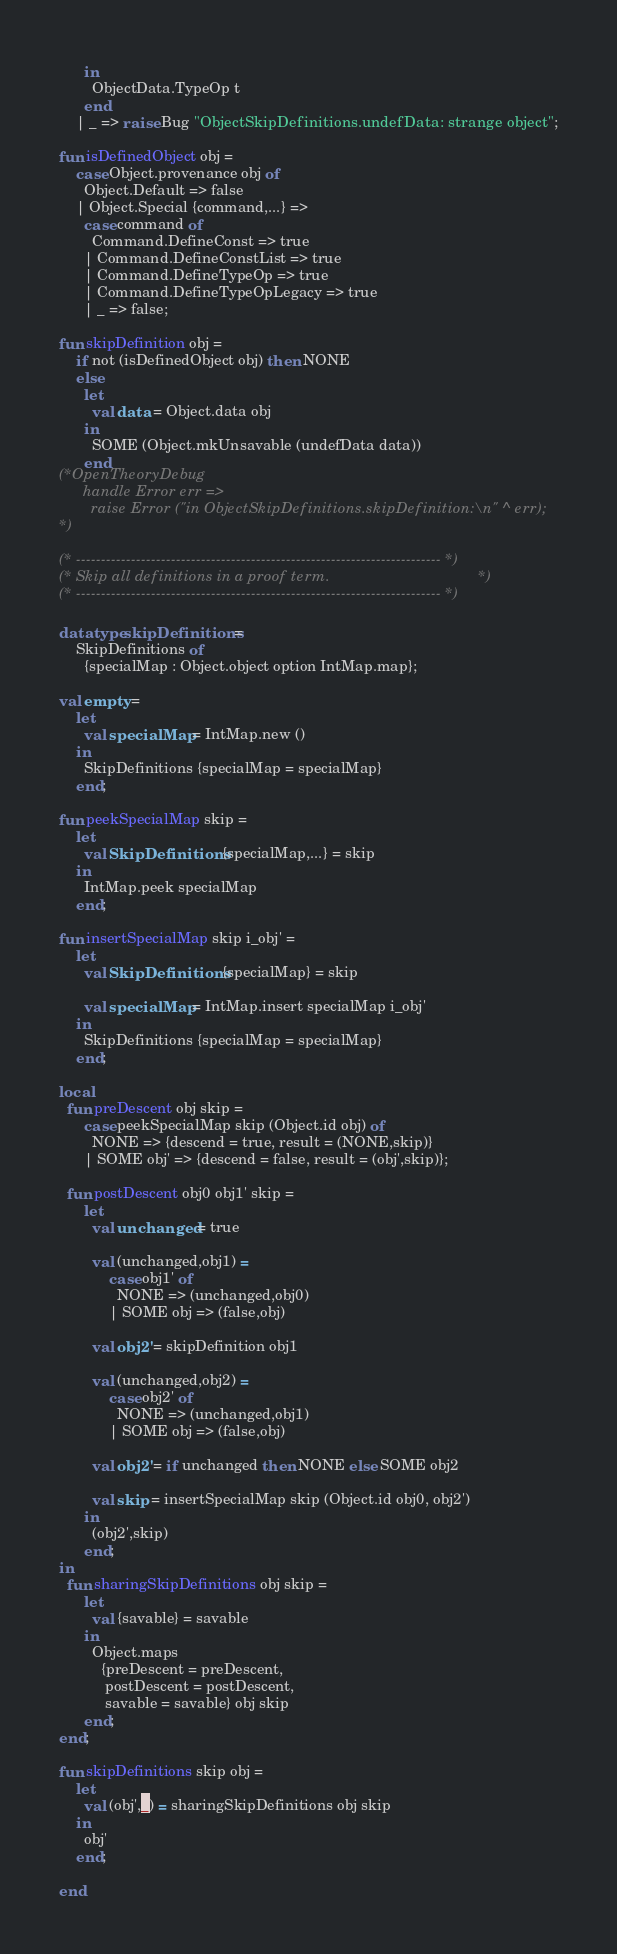<code> <loc_0><loc_0><loc_500><loc_500><_SML_>      in
        ObjectData.TypeOp t
      end
    | _ => raise Bug "ObjectSkipDefinitions.undefData: strange object";

fun isDefinedObject obj =
    case Object.provenance obj of
      Object.Default => false
    | Object.Special {command,...} =>
      case command of
        Command.DefineConst => true
      | Command.DefineConstList => true
      | Command.DefineTypeOp => true
      | Command.DefineTypeOpLegacy => true
      | _ => false;

fun skipDefinition obj =
    if not (isDefinedObject obj) then NONE
    else
      let
        val data = Object.data obj
      in
        SOME (Object.mkUnsavable (undefData data))
      end
(*OpenTheoryDebug
      handle Error err =>
        raise Error ("in ObjectSkipDefinitions.skipDefinition:\n" ^ err);
*)

(* ------------------------------------------------------------------------- *)
(* Skip all definitions in a proof term.                                     *)
(* ------------------------------------------------------------------------- *)

datatype skipDefinitions =
    SkipDefinitions of
      {specialMap : Object.object option IntMap.map};

val empty =
    let
      val specialMap = IntMap.new ()
    in
      SkipDefinitions {specialMap = specialMap}
    end;

fun peekSpecialMap skip =
    let
      val SkipDefinitions {specialMap,...} = skip
    in
      IntMap.peek specialMap
    end;

fun insertSpecialMap skip i_obj' =
    let
      val SkipDefinitions {specialMap} = skip

      val specialMap = IntMap.insert specialMap i_obj'
    in
      SkipDefinitions {specialMap = specialMap}
    end;

local
  fun preDescent obj skip =
      case peekSpecialMap skip (Object.id obj) of
        NONE => {descend = true, result = (NONE,skip)}
      | SOME obj' => {descend = false, result = (obj',skip)};

  fun postDescent obj0 obj1' skip =
      let
        val unchanged = true

        val (unchanged,obj1) =
            case obj1' of
              NONE => (unchanged,obj0)
            | SOME obj => (false,obj)

        val obj2' = skipDefinition obj1

        val (unchanged,obj2) =
            case obj2' of
              NONE => (unchanged,obj1)
            | SOME obj => (false,obj)

        val obj2' = if unchanged then NONE else SOME obj2

        val skip = insertSpecialMap skip (Object.id obj0, obj2')
      in
        (obj2',skip)
      end;
in
  fun sharingSkipDefinitions obj skip =
      let
        val {savable} = savable
      in
        Object.maps
          {preDescent = preDescent,
           postDescent = postDescent,
           savable = savable} obj skip
      end;
end;

fun skipDefinitions skip obj =
    let
      val (obj',_) = sharingSkipDefinitions obj skip
    in
      obj'
    end;

end
</code> 